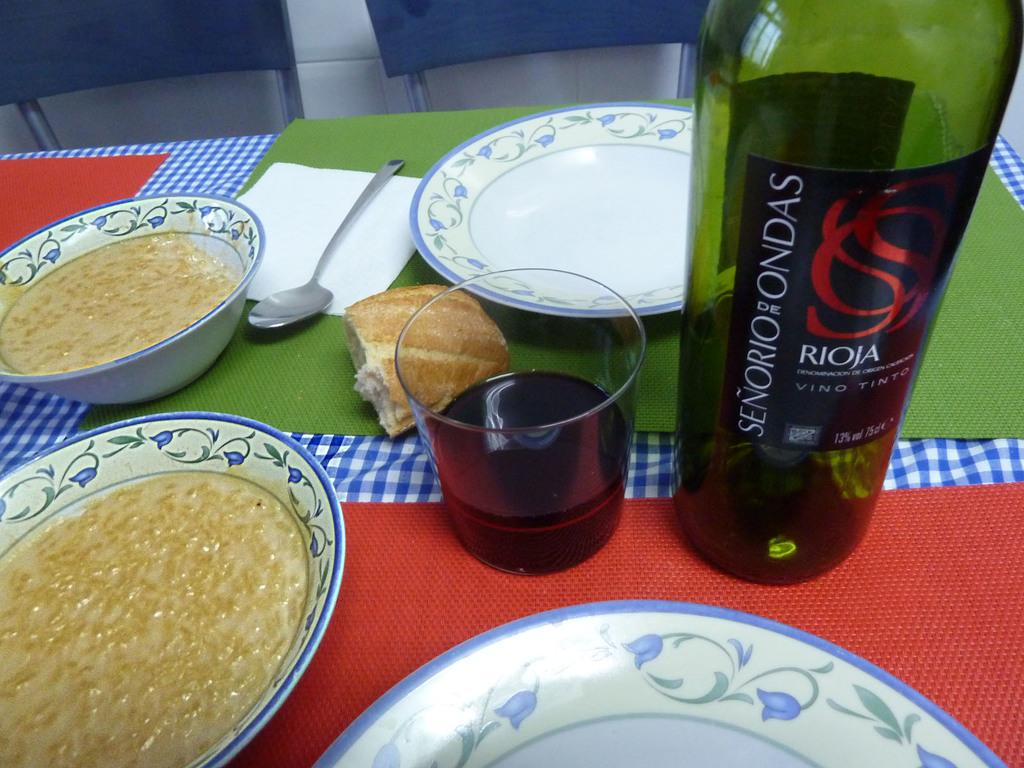<image>
Create a compact narrative representing the image presented. A bottle of Vino Tinto sits on the table next to a simple meal. 